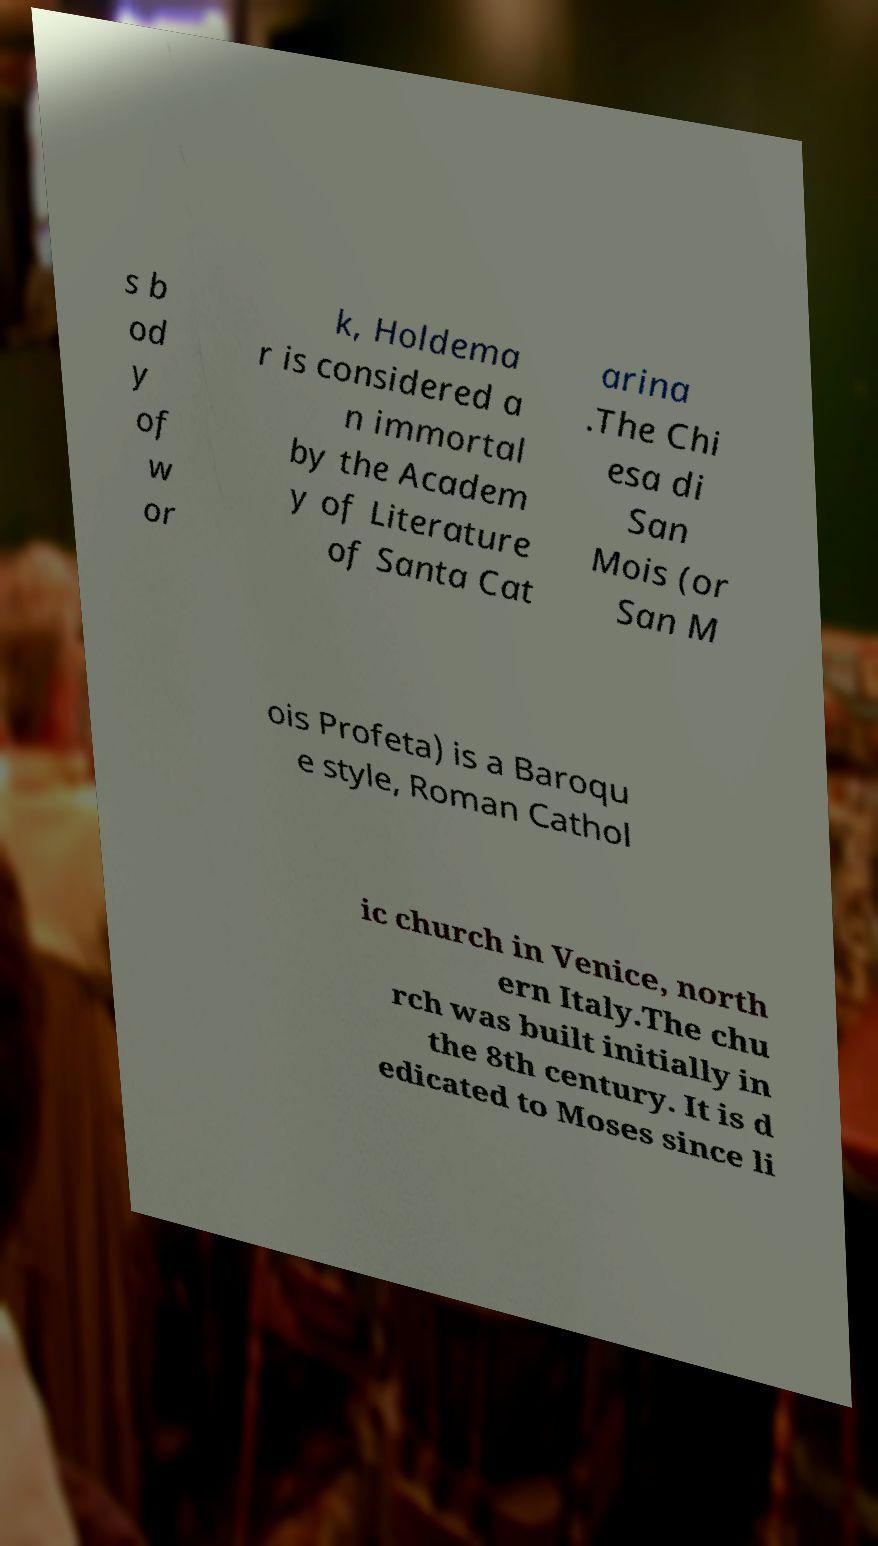Can you read and provide the text displayed in the image?This photo seems to have some interesting text. Can you extract and type it out for me? s b od y of w or k, Holdema r is considered a n immortal by the Academ y of Literature of Santa Cat arina .The Chi esa di San Mois (or San M ois Profeta) is a Baroqu e style, Roman Cathol ic church in Venice, north ern Italy.The chu rch was built initially in the 8th century. It is d edicated to Moses since li 